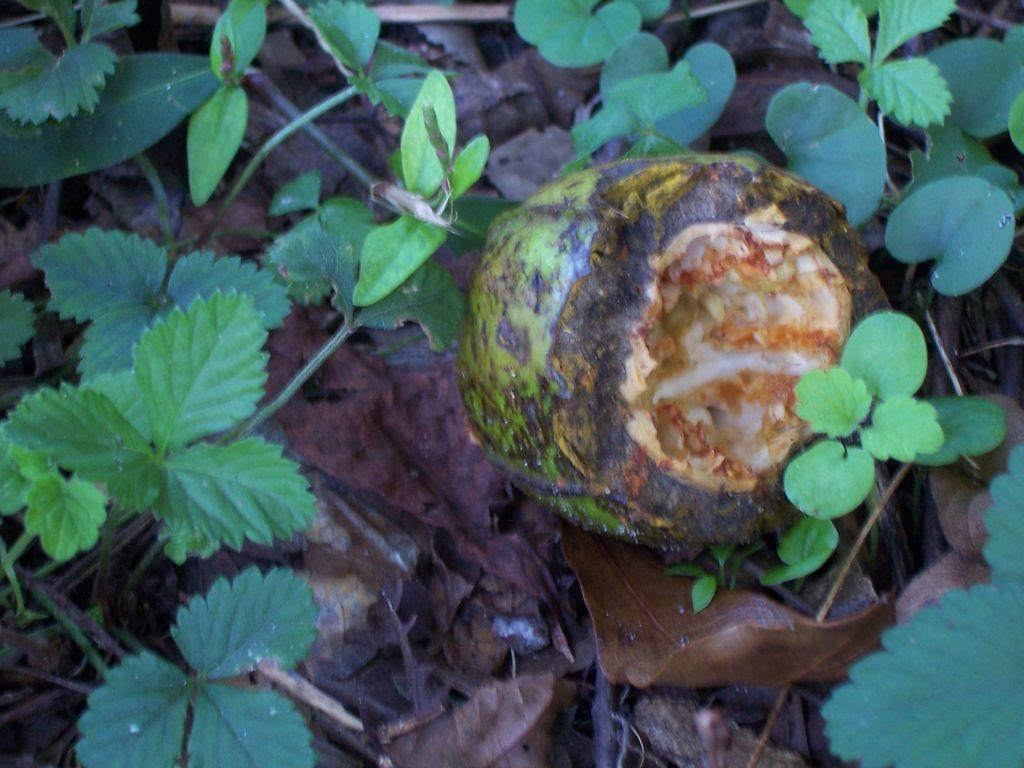What is the main subject in the middle of the image? There is a fruit in the middle of the image. What other types of plants can be seen in the image? There are herbs visible in the image. What is located at the bottom of the image? Dry leaves and twigs are present at the bottom of the image. How many partners are visible in the image? There are no partners present in the image; it features a fruit, herbs, and dry leaves and twigs. What type of line can be seen connecting the fruit and herbs in the image? There is no line connecting the fruit and herbs in the image; they are separate elements in the image. 